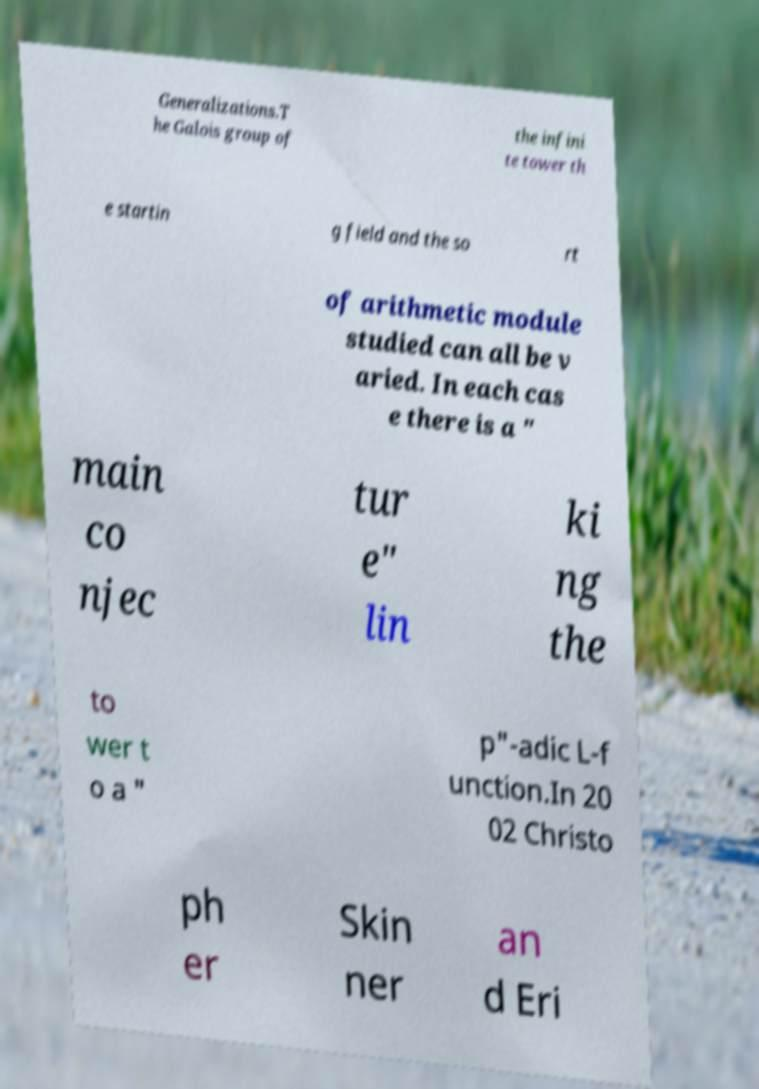What messages or text are displayed in this image? I need them in a readable, typed format. Generalizations.T he Galois group of the infini te tower th e startin g field and the so rt of arithmetic module studied can all be v aried. In each cas e there is a " main co njec tur e" lin ki ng the to wer t o a " p"-adic L-f unction.In 20 02 Christo ph er Skin ner an d Eri 